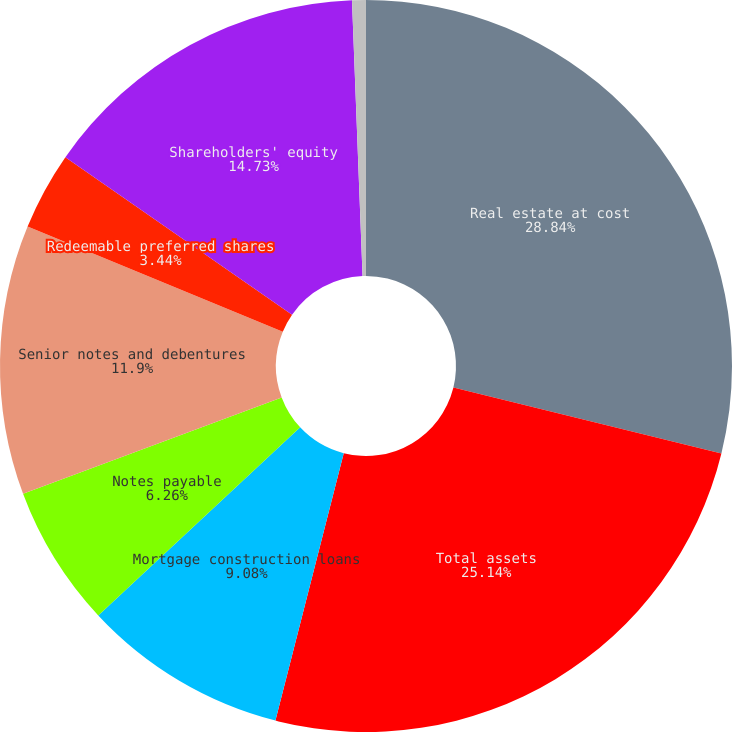Convert chart to OTSL. <chart><loc_0><loc_0><loc_500><loc_500><pie_chart><fcel>Real estate at cost<fcel>Total assets<fcel>Mortgage construction loans<fcel>Notes payable<fcel>Senior notes and debentures<fcel>Redeemable preferred shares<fcel>Shareholders' equity<fcel>Number of common shares<nl><fcel>28.84%<fcel>25.14%<fcel>9.08%<fcel>6.26%<fcel>11.9%<fcel>3.44%<fcel>14.73%<fcel>0.61%<nl></chart> 